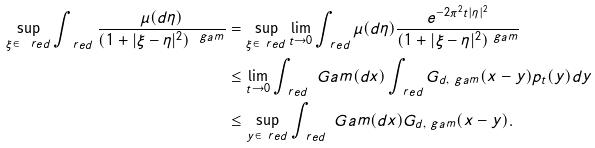<formula> <loc_0><loc_0><loc_500><loc_500>\sup _ { \xi \in \ r e d } \int _ { \ r e d } \frac { \mu ( d \eta ) } { ( 1 + | \xi - \eta | ^ { 2 } ) ^ { \ g a m } } & = \sup _ { \xi \in \ r e d } \lim _ { t \to 0 } \int _ { \ r e d } \mu ( d \eta ) \frac { e ^ { - 2 \pi ^ { 2 } t | \eta | ^ { 2 } } } { ( 1 + | \xi - \eta | ^ { 2 } ) ^ { \ g a m } } \\ & \leq \lim _ { t \to 0 } \int _ { \ r e d } \ G a m ( d x ) \int _ { \ r e d } G _ { d , \ g a m } ( x - y ) p _ { t } ( y ) d y \\ & \leq \sup _ { y \in \ r e d } \int _ { \ r e d } \ G a m ( d x ) G _ { d , \ g a m } ( x - y ) .</formula> 